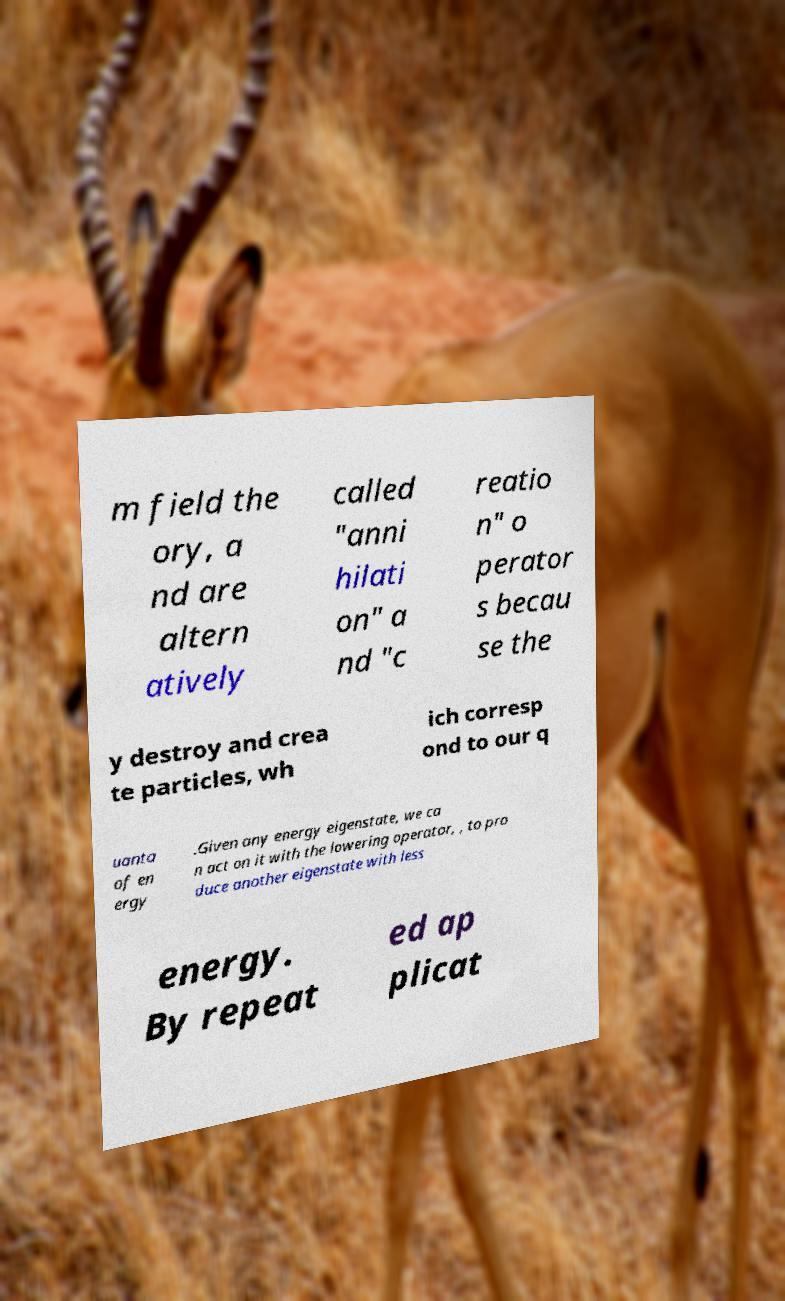There's text embedded in this image that I need extracted. Can you transcribe it verbatim? m field the ory, a nd are altern atively called "anni hilati on" a nd "c reatio n" o perator s becau se the y destroy and crea te particles, wh ich corresp ond to our q uanta of en ergy .Given any energy eigenstate, we ca n act on it with the lowering operator, , to pro duce another eigenstate with less energy. By repeat ed ap plicat 